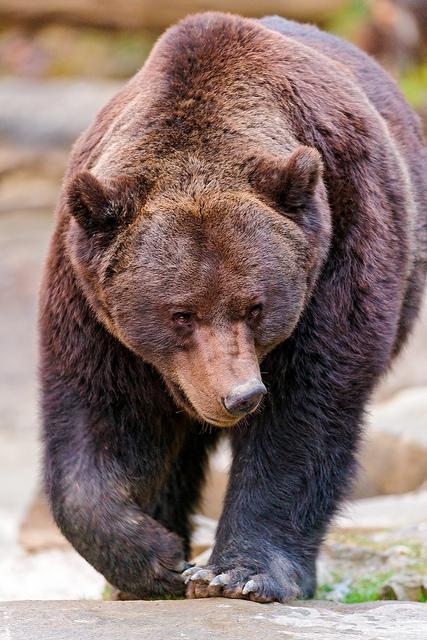How many people are shown?
Give a very brief answer. 0. 